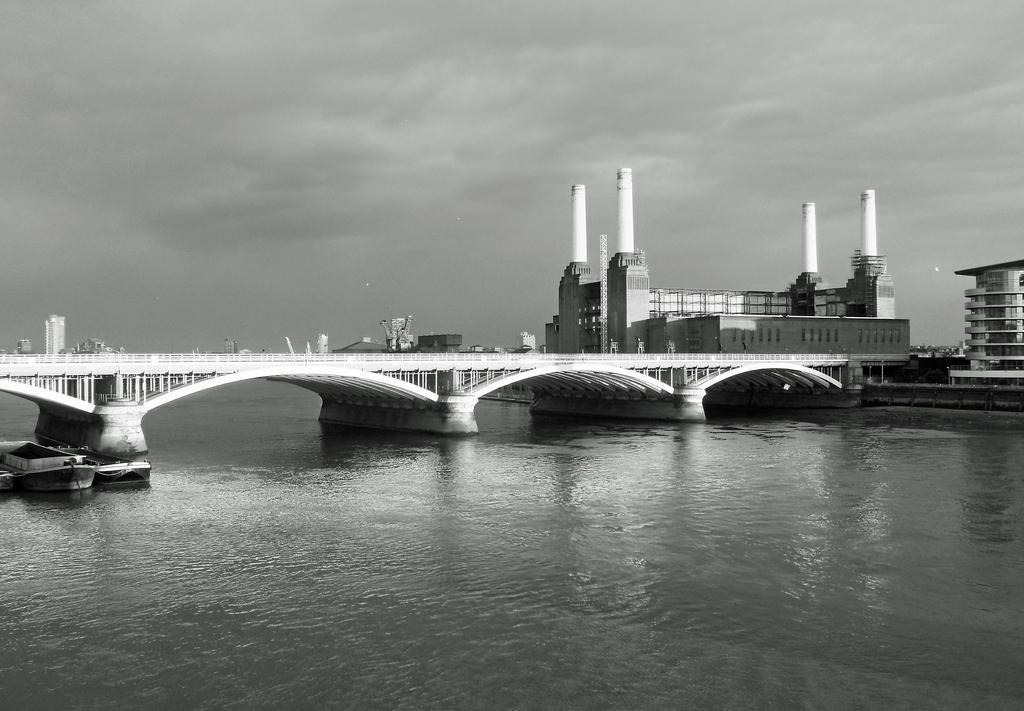What structure can be seen in the image that connects two areas? There is a bridge in the image that connects two areas. What is located under the bridge? There is water under the bridge. What type of vehicles can be seen on the water? There are boats on the water. What type of structures can be seen in the image besides the bridge? There are buildings visible in the image. What can be seen in the background of the image? The sky is visible in the background of the image. What type of copper material is used to construct the table in the image? There is no table present in the image, so it is not possible to determine the type of copper material used in its construction. 